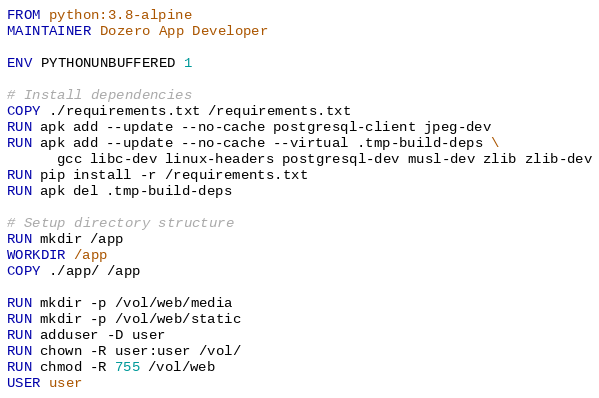<code> <loc_0><loc_0><loc_500><loc_500><_Dockerfile_>FROM python:3.8-alpine
MAINTAINER Dozero App Developer

ENV PYTHONUNBUFFERED 1

# Install dependencies
COPY ./requirements.txt /requirements.txt
RUN apk add --update --no-cache postgresql-client jpeg-dev
RUN apk add --update --no-cache --virtual .tmp-build-deps \
      gcc libc-dev linux-headers postgresql-dev musl-dev zlib zlib-dev
RUN pip install -r /requirements.txt
RUN apk del .tmp-build-deps

# Setup directory structure
RUN mkdir /app
WORKDIR /app
COPY ./app/ /app

RUN mkdir -p /vol/web/media
RUN mkdir -p /vol/web/static
RUN adduser -D user
RUN chown -R user:user /vol/
RUN chmod -R 755 /vol/web
USER user
</code> 